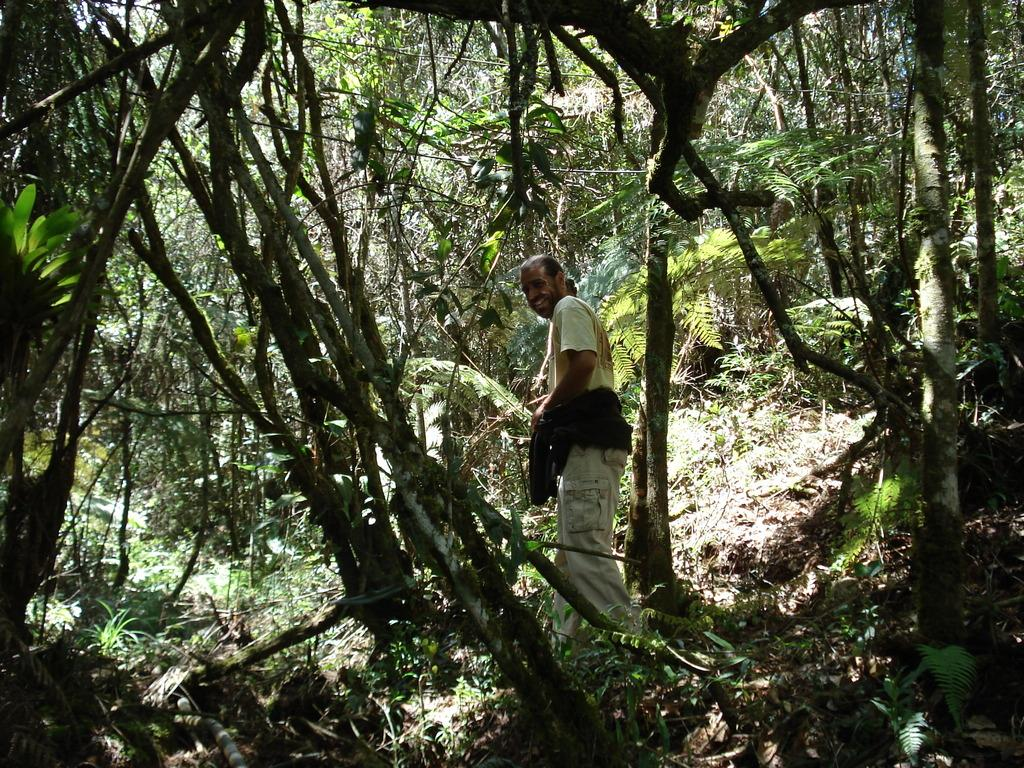Who or what is present in the image? There is a person in the image. What type of vegetation can be seen in the image? There are plants, grass, and trees in the image. How many ducks are visible in the image? There are no ducks present in the image. What type of car can be seen in the image? There is no car present in the image. 